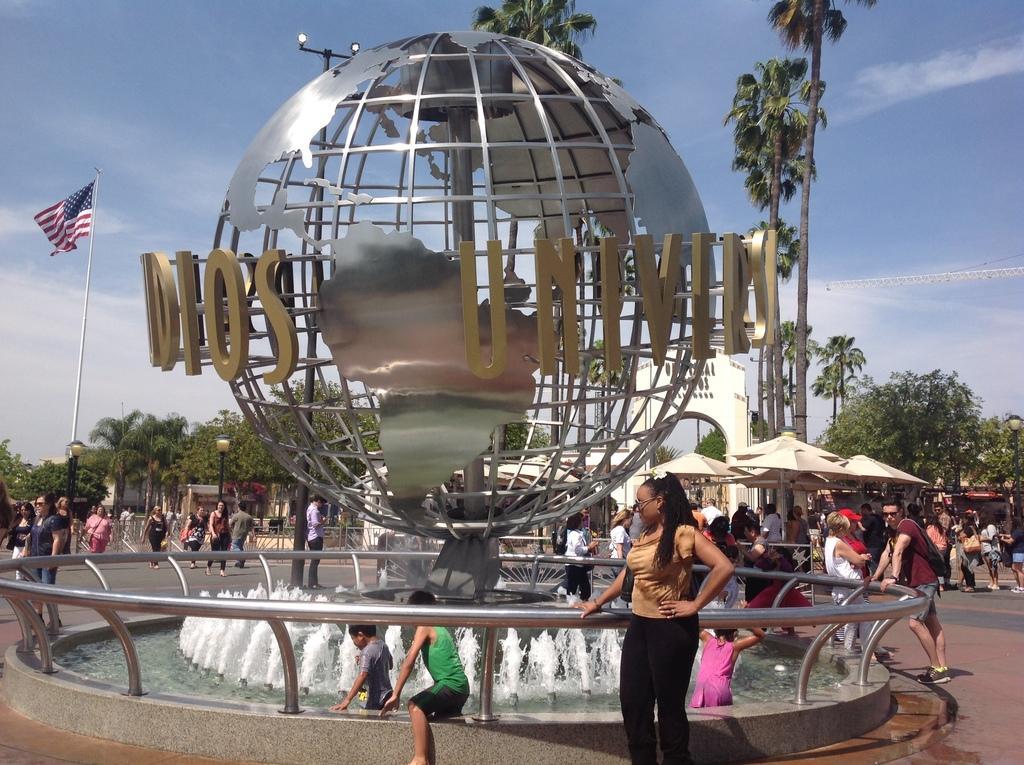Describe this image in one or two sentences. In this picture I can see there are trees, there is a metal globe and there is something written on the globe. There is a fountain here and there are some children in the fountain. In the backdrop there is a flag and there are trees. 